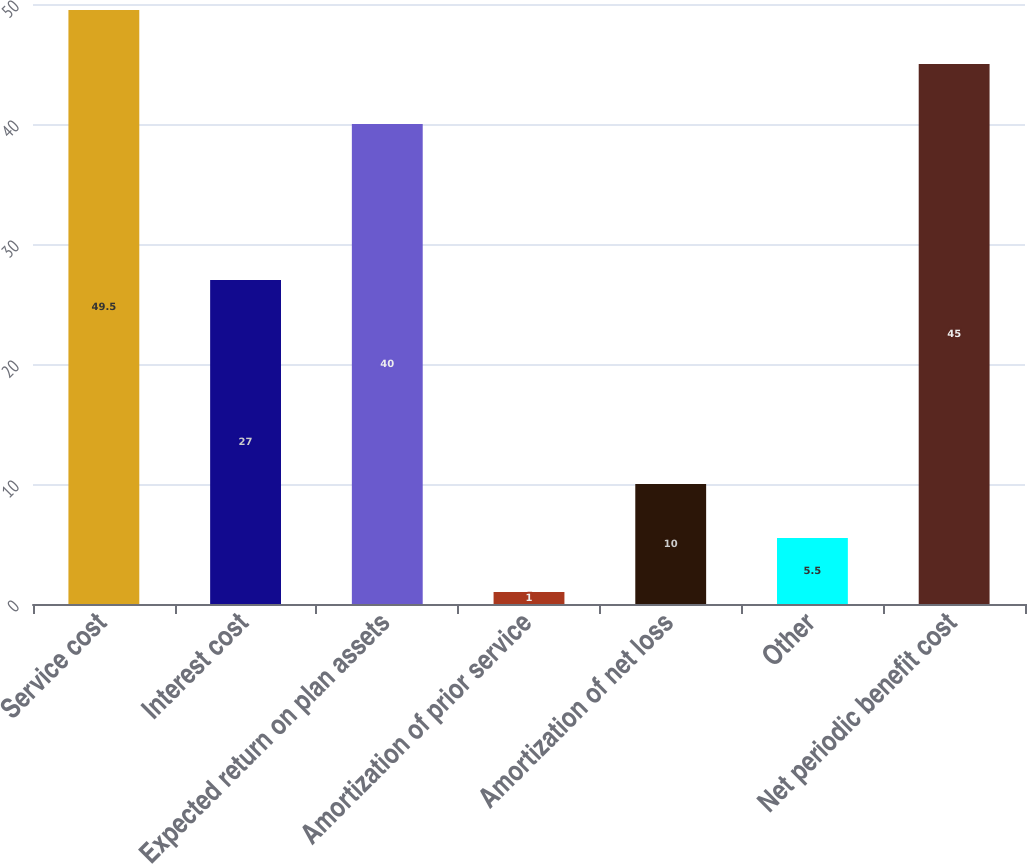Convert chart to OTSL. <chart><loc_0><loc_0><loc_500><loc_500><bar_chart><fcel>Service cost<fcel>Interest cost<fcel>Expected return on plan assets<fcel>Amortization of prior service<fcel>Amortization of net loss<fcel>Other<fcel>Net periodic benefit cost<nl><fcel>49.5<fcel>27<fcel>40<fcel>1<fcel>10<fcel>5.5<fcel>45<nl></chart> 